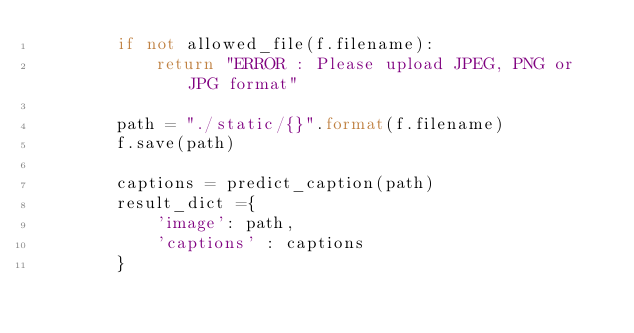Convert code to text. <code><loc_0><loc_0><loc_500><loc_500><_Python_>        if not allowed_file(f.filename):
            return "ERROR : Please upload JPEG, PNG or JPG format"
        
        path = "./static/{}".format(f.filename)
        f.save(path)
       
        captions = predict_caption(path)
        result_dict ={
            'image': path,
            'captions' : captions
        }
         
    </code> 